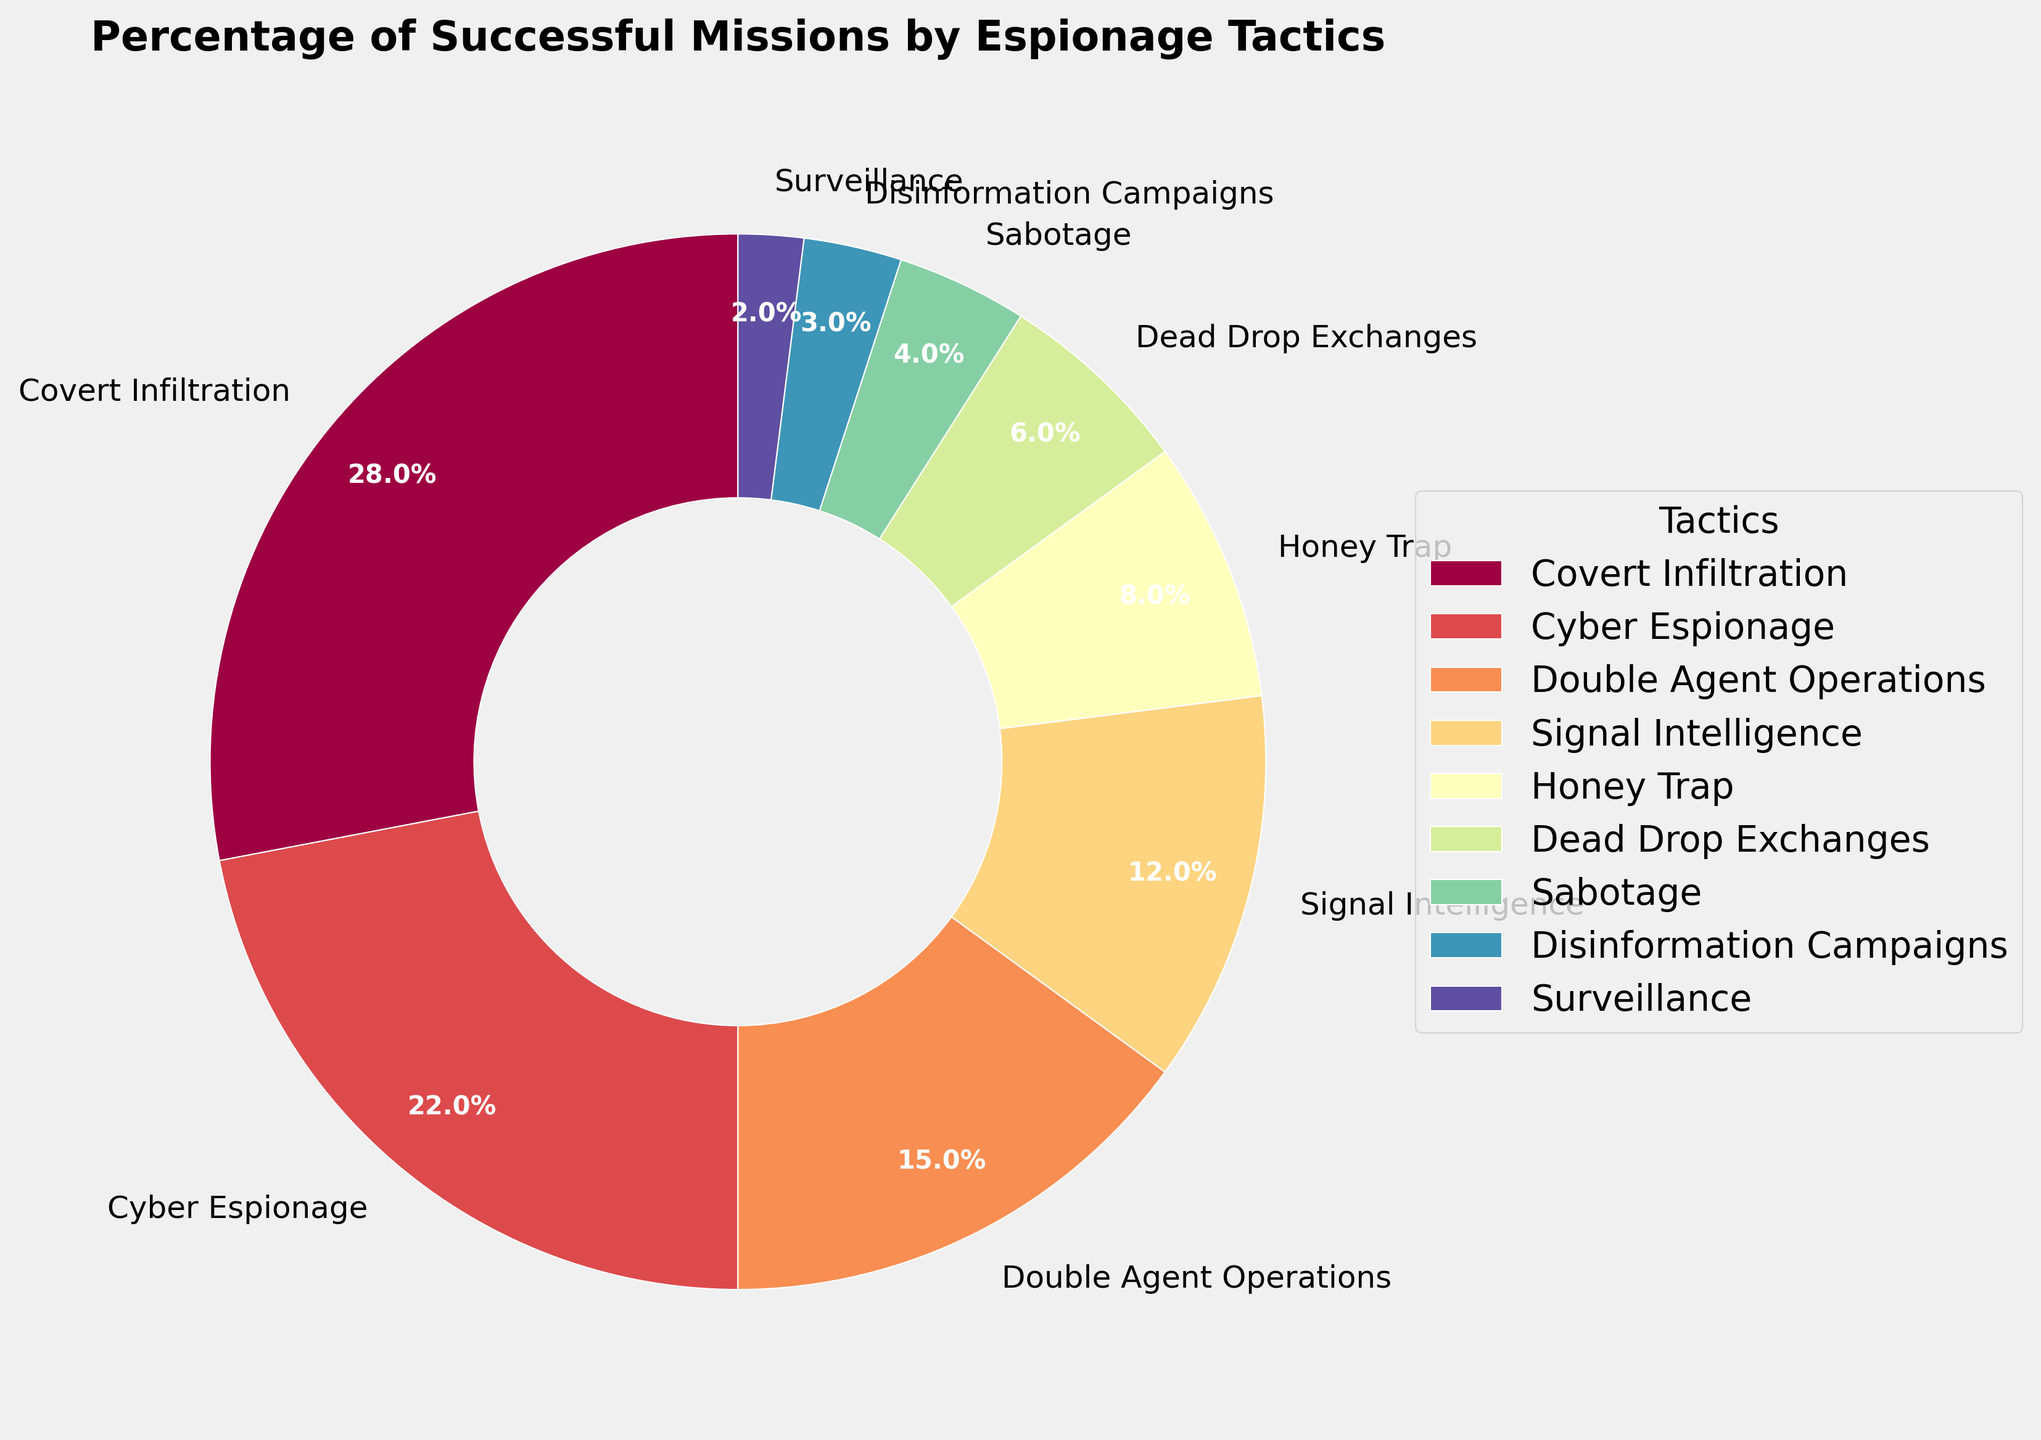what is the percentage of missions succeeded by covert infiltration and surveillance combined? To find the combined percentage, add the percentages of Covert Infiltration (28%) and Surveillance (2%). Thus, 28% + 2% = 30%.
Answer: 30% How does the success rate of Cyber Espionage compare to that of Signal Intelligence? Compare the percentages for Cyber Espionage (22%) and Signal Intelligence (12%). Cyber Espionage has a higher success rate than Signal Intelligence by 10%.
Answer: Cyber Espionage has a 10% higher success rate Which tactic has the least percentage of successful missions? Look at the pie chart for the smallest wedge. Disinformation Campaigns have the smallest wedge with 3%.
Answer: Disinformation Campaigns Which tactic contributes most to the overall success rate? Identify the tactic with the largest wedge. Covert Infiltration has the largest wedge with 28%.
Answer: Covert Infiltration How many tactics have a successful mission rate above 10%? Count the wedges with percentages above 10%: Covert Infiltration (28%), Cyber Espionage (22%), Double Agent Operations (15%), and Signal Intelligence (12%). There are 4 tactics.
Answer: 4 Among Honey Trap, Dead Drop Exchanges, and Sabotage, which has the highest success rate and by what margin? Compare the percentages: Honey Trap (8%), Dead Drop Exchanges (6%), and Sabotage (4%). Honey Trap has the highest success rate at 8%. The margin compared to the next highest (Dead Drop Exchanges) is 8% - 6% = 2%.
Answer: Honey Trap by 2% What is the average success rate of Honey Trap, Dead Drop Exchanges, and Disinformation Campaigns? Add the percentages of Honey Trap (8%), Dead Drop Exchanges (6%), and Disinformation Campaigns (3%) and divide by 3. (8% + 6% + 3%) / 3 = 17% / 3 ≈ 5.67%.
Answer: 5.67% Is the difference between Signal Intelligence and Double Agent Operations' success rates bigger or smaller than the difference between Dead Drop Exchanges and Sabotage? Calculate the differences. Signal Intelligence (12%) - Double Agent Operations (15%) = -3%. Dead Drop Exchanges (6%) - Sabotage (4%) = 2%. The difference between Signal Intelligence and Double Agent Operations (-3%) is bigger in absolute terms than between Dead Drop Exchanges and Sabotage (2%).
Answer: Bigger in absolute terms Which tactic's section is visually closest in size to Cyber Espionage's? Cyber Espionage is 22%, and visually, Double Agent Operations (15%) is closest in size.
Answer: Double Agent Operations 